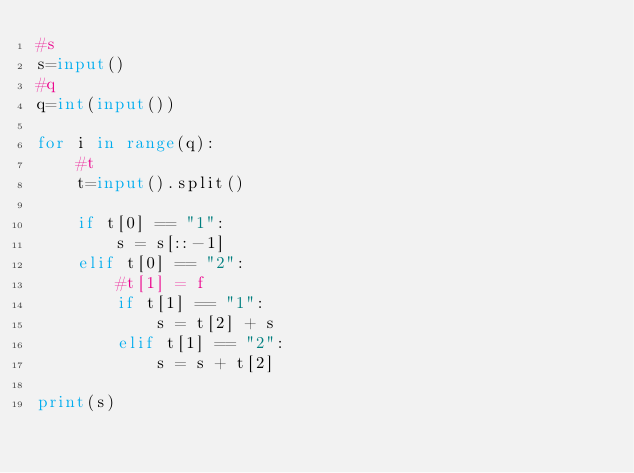<code> <loc_0><loc_0><loc_500><loc_500><_Python_>#s
s=input()
#q
q=int(input())

for i in range(q):
    #t
    t=input().split()

    if t[0] == "1":
        s = s[::-1]
    elif t[0] == "2":
        #t[1] = f
        if t[1] == "1":
            s = t[2] + s
        elif t[1] == "2":
            s = s + t[2]

print(s)
</code> 